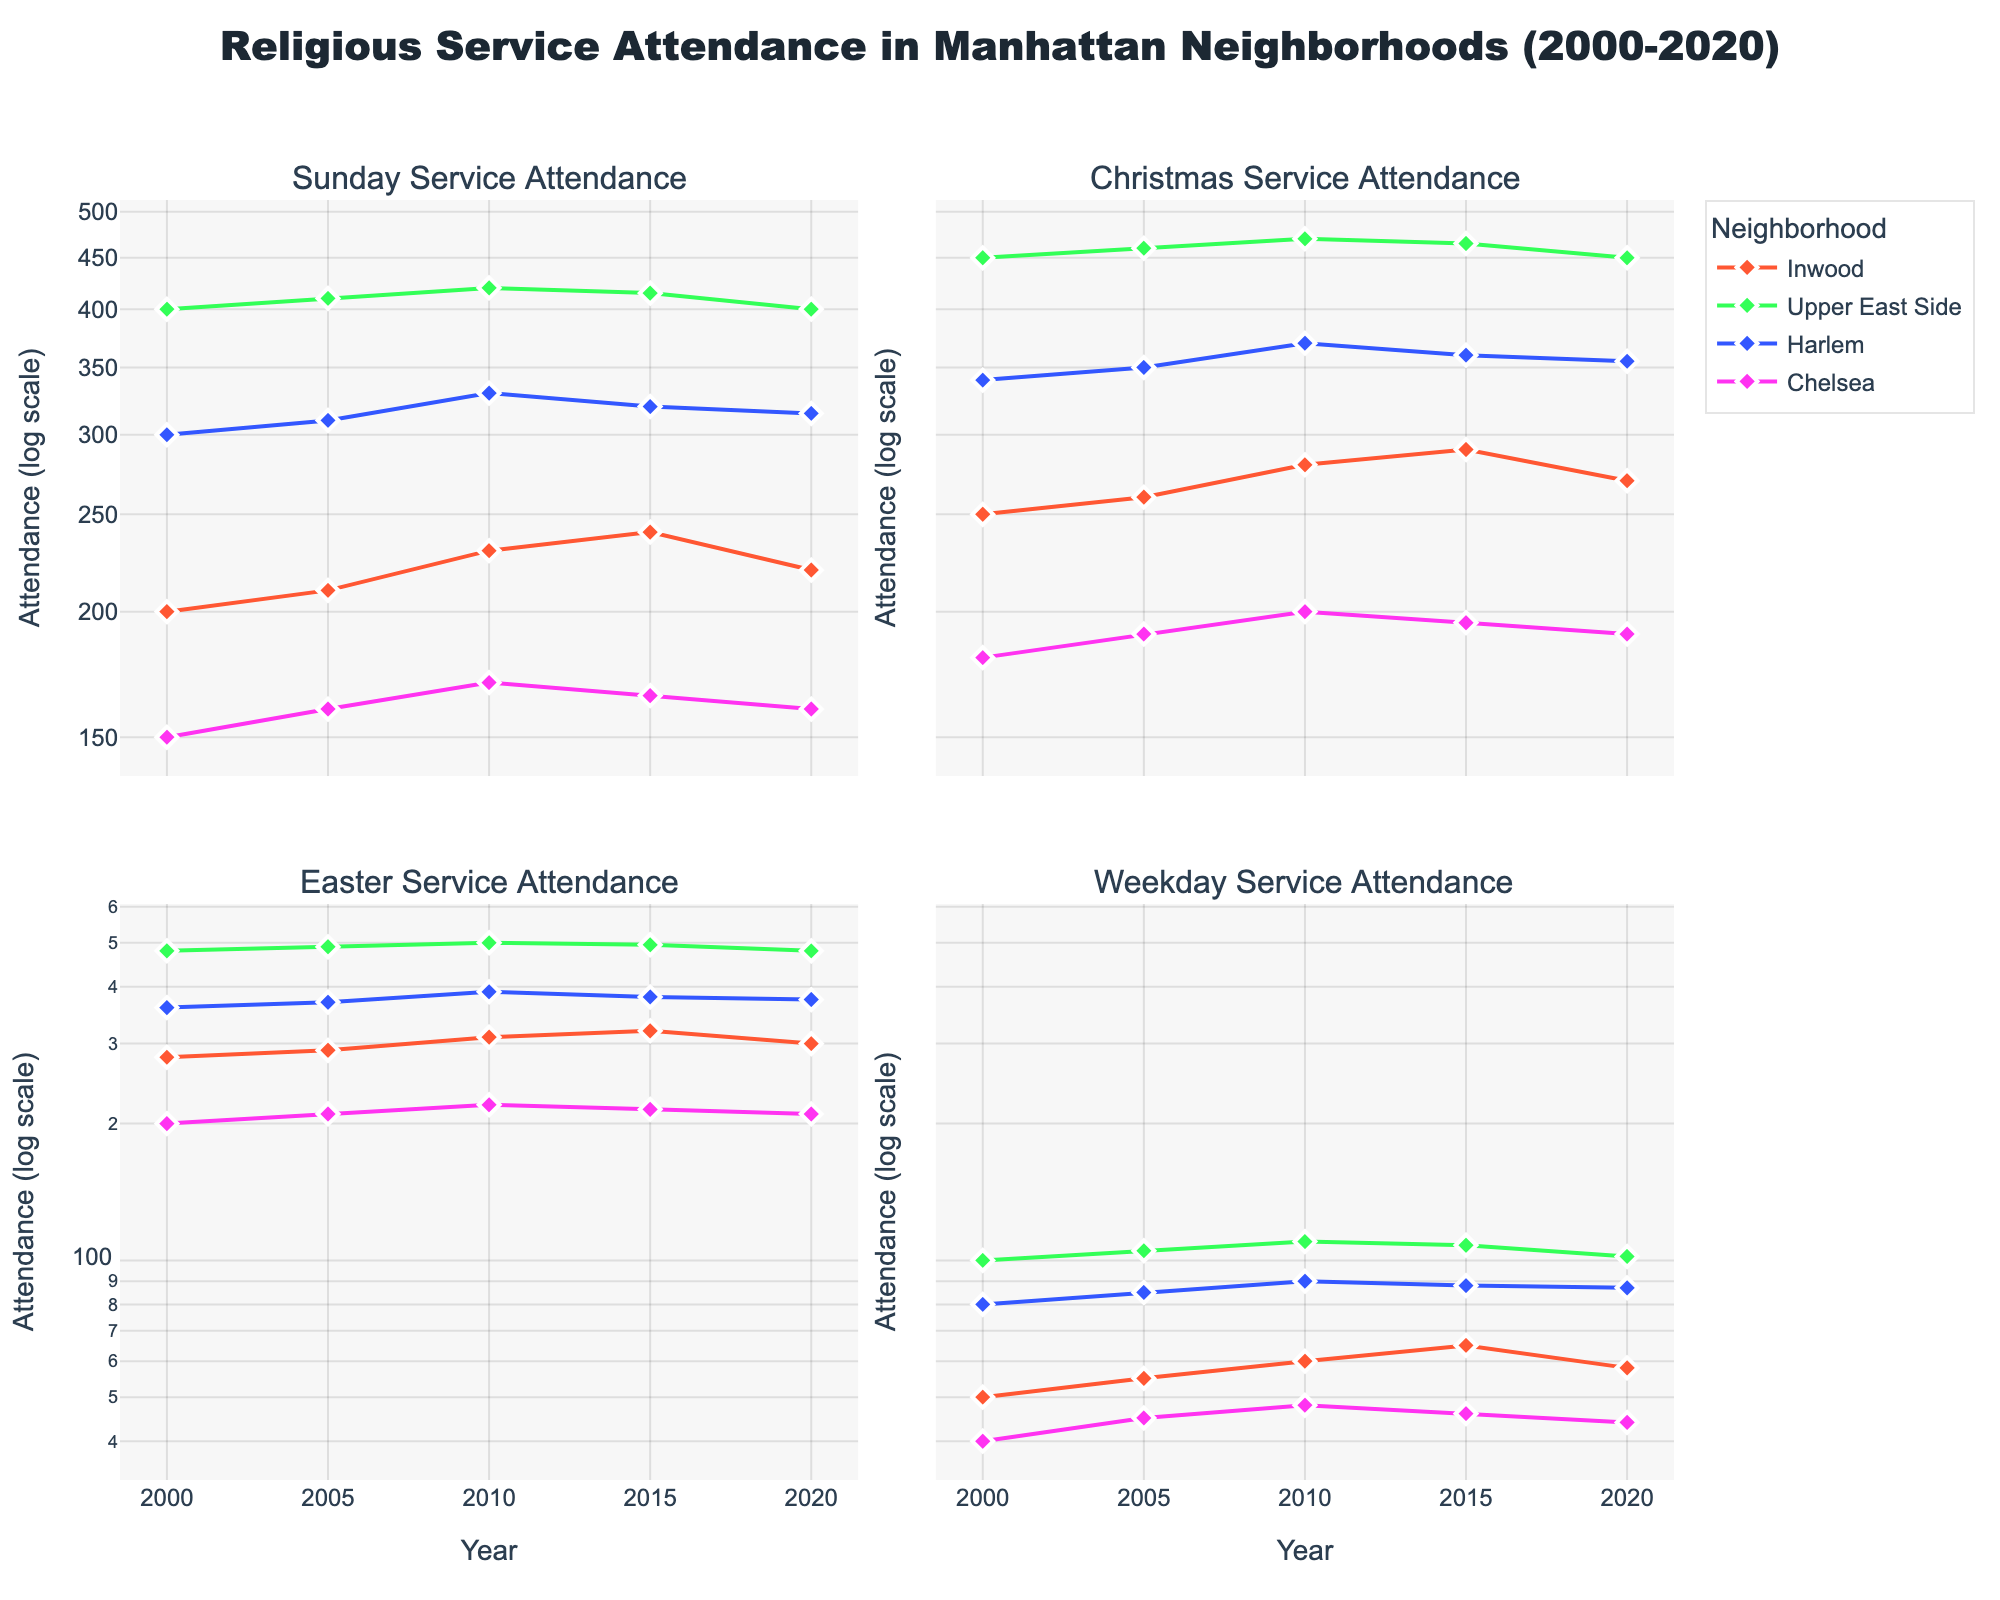What is the title of the figure? The title is displayed at the top center of the figure in large, bold font. It summarizes the main topic of the figure.
Answer: Religious Service Attendance in Manhattan Neighborhoods (2000-2020) Which neighborhood had the highest Easter Service attendance in 2010? Look at the subplot titled "Easter Service Attendance." Find the line corresponding to each neighborhood for the year 2010. Look for the highest y-value (Easter Service attendance) for that year.
Answer: Upper East Side What trend is visible for Weekday Service attendance in Inwood from 2000 to 2020? Locate the subplot titled "Weekday Service Attendance" and look at the line for Inwood. Note the y-values (attendance numbers) along the years. Identify whether they increase, decrease, or remain stable over time.
Answer: Increasing trend until 2015, then slightly decreasing How does Sunday Service attendance in Chelsea in 2020 compare to that in 2000? Find the y-values for Chelsea in the "Sunday Service Attendance" subplot for the years 2000 and 2020. Compare these two values to see if there is an increase, decrease, or if they are the same.
Answer: Decrease Which service type shows the highest variance in attendance for the Upper East Side? Compare the lines for the Upper East Side in each subplot. Note the spread of y-values over the years for Sunday Service, Christmas Service, Easter Service, and Weekday Service. Identify the service type with the widest range of attendance values.
Answer: Easter Service Attendance How did Christmas Service attendance change in Harlem from 2005 to 2015? Look at the subplot titled "Christmas Service Attendance" and trace the line for Harlem. Observe the y-values at 2005 and 2015. Calculate the difference or describe the trend.
Answer: Increase Which neighborhood had the smallest change in Weekday Service attendance from 2000 to 2020? Observe the subplot titled "Weekday Service Attendance"; compare the y-values for all neighborhoods at 2000 and 2020. Find the neighborhood with the smallest difference.
Answer: Chelsea Arrange the neighborhoods in ascending order based on their Sunday Service attendance in 2020. Look at the y-values for Sunday Service Attendance in the year 2020 for each neighborhood. List these values in ascending order and then order the neighborhoods accordingly.
Answer: Chelsea, Inwood, Harlem, Upper East Side What is the overall impression of religious service attendance trends in Manhattan neighborhoods? Evaluate the trends in all subplots. Note any overarching patterns, such as consistent increases/decreases or variability in attendance across different neighborhoods and services.
Answer: Generally stable with some fluctuations Is there any neighborhood that shows a noticeable anomaly in any service type? Scan through each subplot and look for any irregular spikes, drops, or trends that stand out in a neighborhood's attendance data. Specify the service type and year if such an anomaly exists.
Answer: No major anomalies 